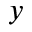<formula> <loc_0><loc_0><loc_500><loc_500>y</formula> 